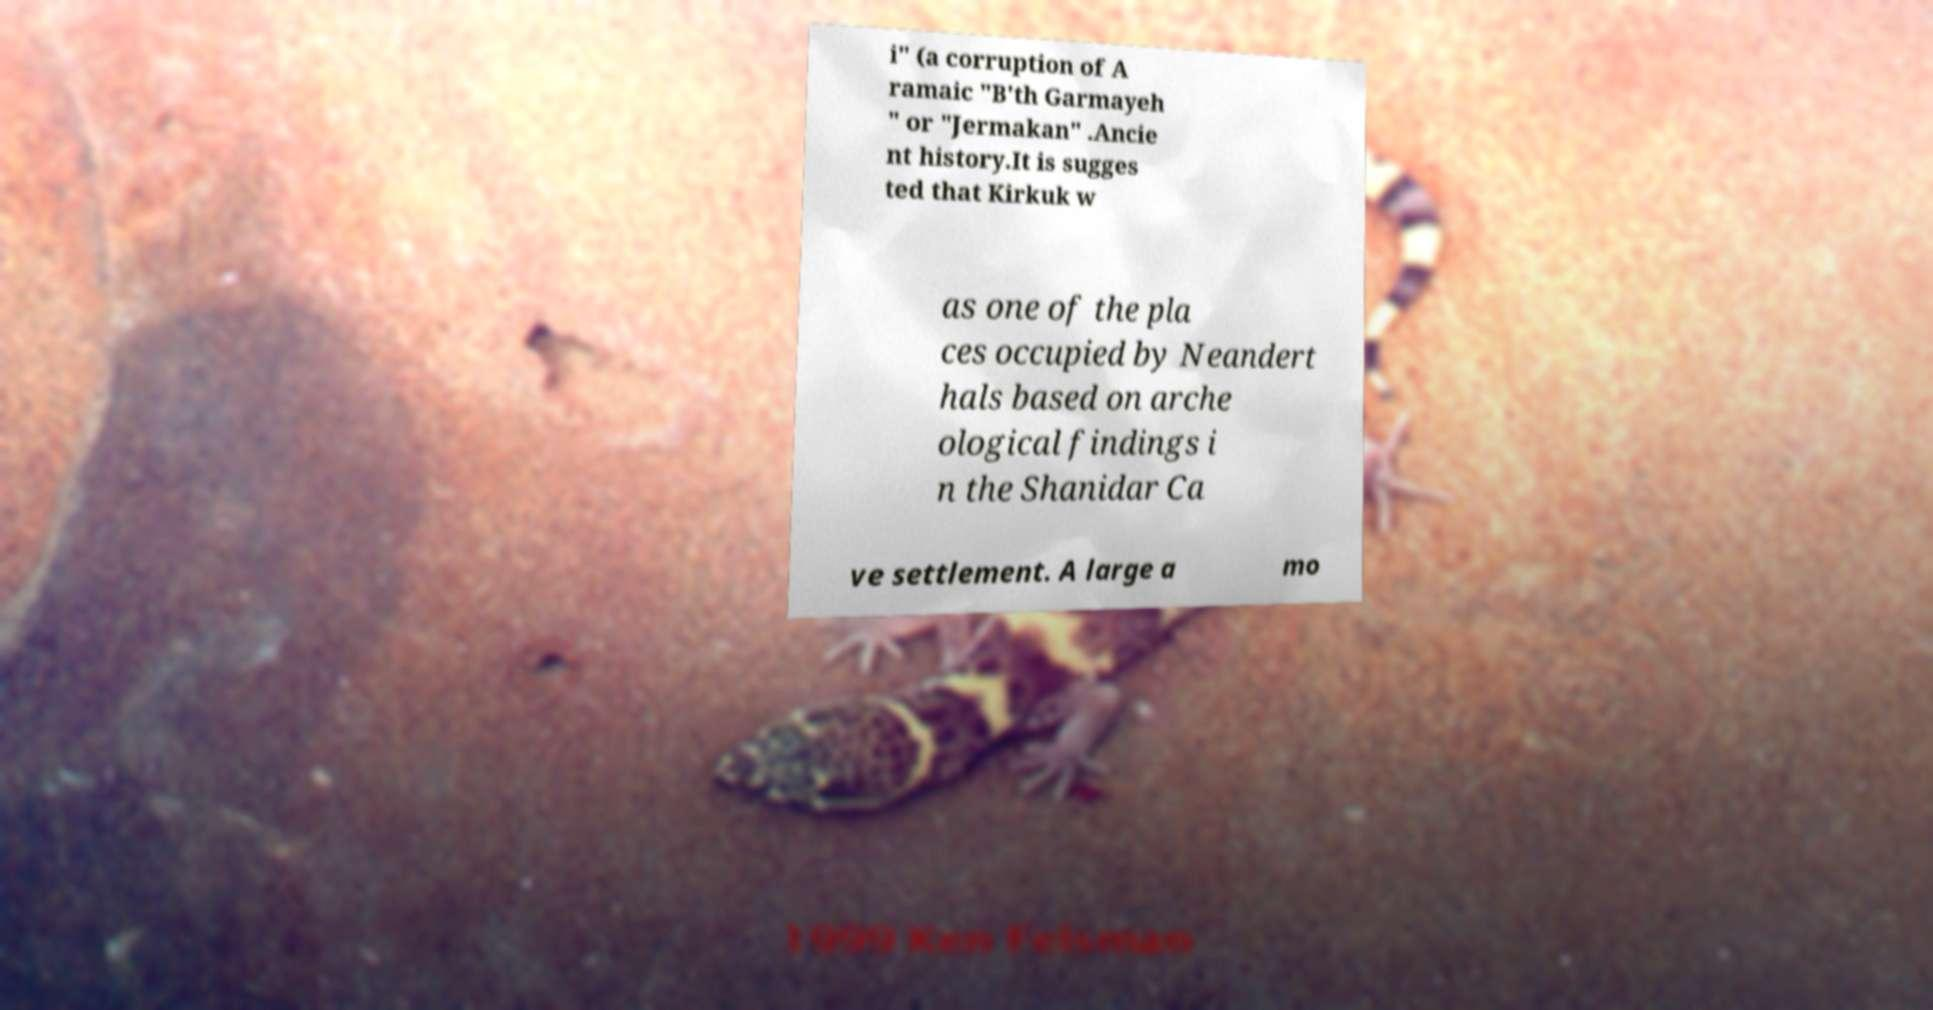Please identify and transcribe the text found in this image. i" (a corruption of A ramaic "B'th Garmayeh " or "Jermakan" .Ancie nt history.It is sugges ted that Kirkuk w as one of the pla ces occupied by Neandert hals based on arche ological findings i n the Shanidar Ca ve settlement. A large a mo 